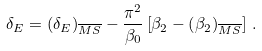Convert formula to latex. <formula><loc_0><loc_0><loc_500><loc_500>\delta _ { E } = \left ( \delta _ { E } \right ) _ { \overline { M S } } - \frac { \pi ^ { 2 } } { \beta _ { 0 } } \left [ \beta _ { 2 } - \left ( \beta _ { 2 } \right ) _ { \overline { M S } } \right ] \, .</formula> 